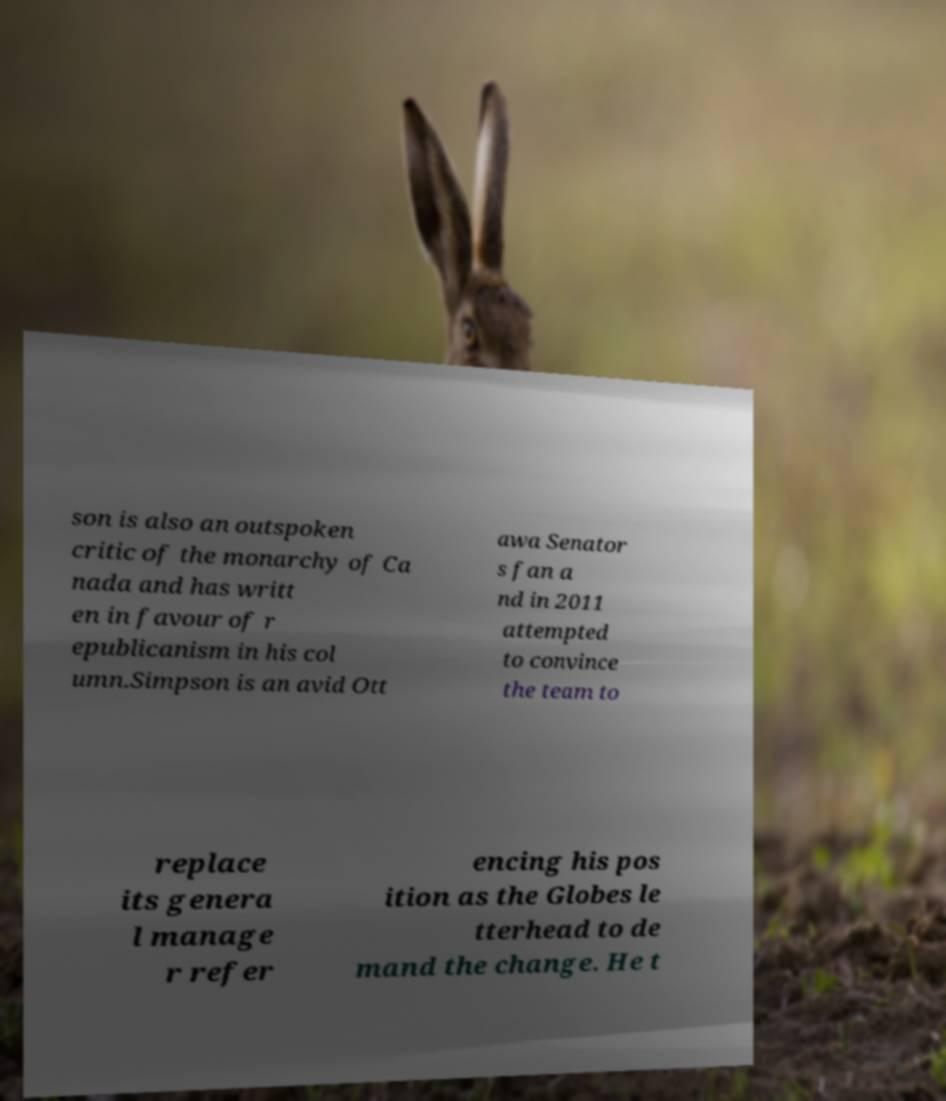I need the written content from this picture converted into text. Can you do that? son is also an outspoken critic of the monarchy of Ca nada and has writt en in favour of r epublicanism in his col umn.Simpson is an avid Ott awa Senator s fan a nd in 2011 attempted to convince the team to replace its genera l manage r refer encing his pos ition as the Globes le tterhead to de mand the change. He t 